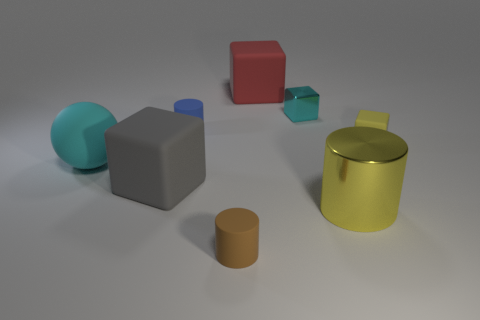There is a tiny block on the left side of the big object right of the large thing behind the small blue rubber thing; what is its material?
Provide a short and direct response. Metal. What number of objects are large purple matte cylinders or matte cubes?
Ensure brevity in your answer.  3. There is a matte object that is on the right side of the red cube; is it the same color as the cylinder to the right of the brown rubber object?
Your answer should be compact. Yes. What is the shape of the yellow matte thing that is the same size as the cyan block?
Offer a terse response. Cube. What number of objects are either small blocks left of the yellow metal object or small things behind the brown object?
Your answer should be very brief. 3. Is the number of small shiny blocks less than the number of large yellow cubes?
Offer a terse response. No. What is the material of the cylinder that is the same size as the cyan matte thing?
Keep it short and to the point. Metal. There is a metal object in front of the blue thing; does it have the same size as the rubber object behind the blue cylinder?
Your answer should be very brief. Yes. Is there a tiny green cube made of the same material as the tiny blue thing?
Your response must be concise. No. How many things are either yellow objects that are behind the yellow metal object or large red rubber cubes?
Your response must be concise. 2. 